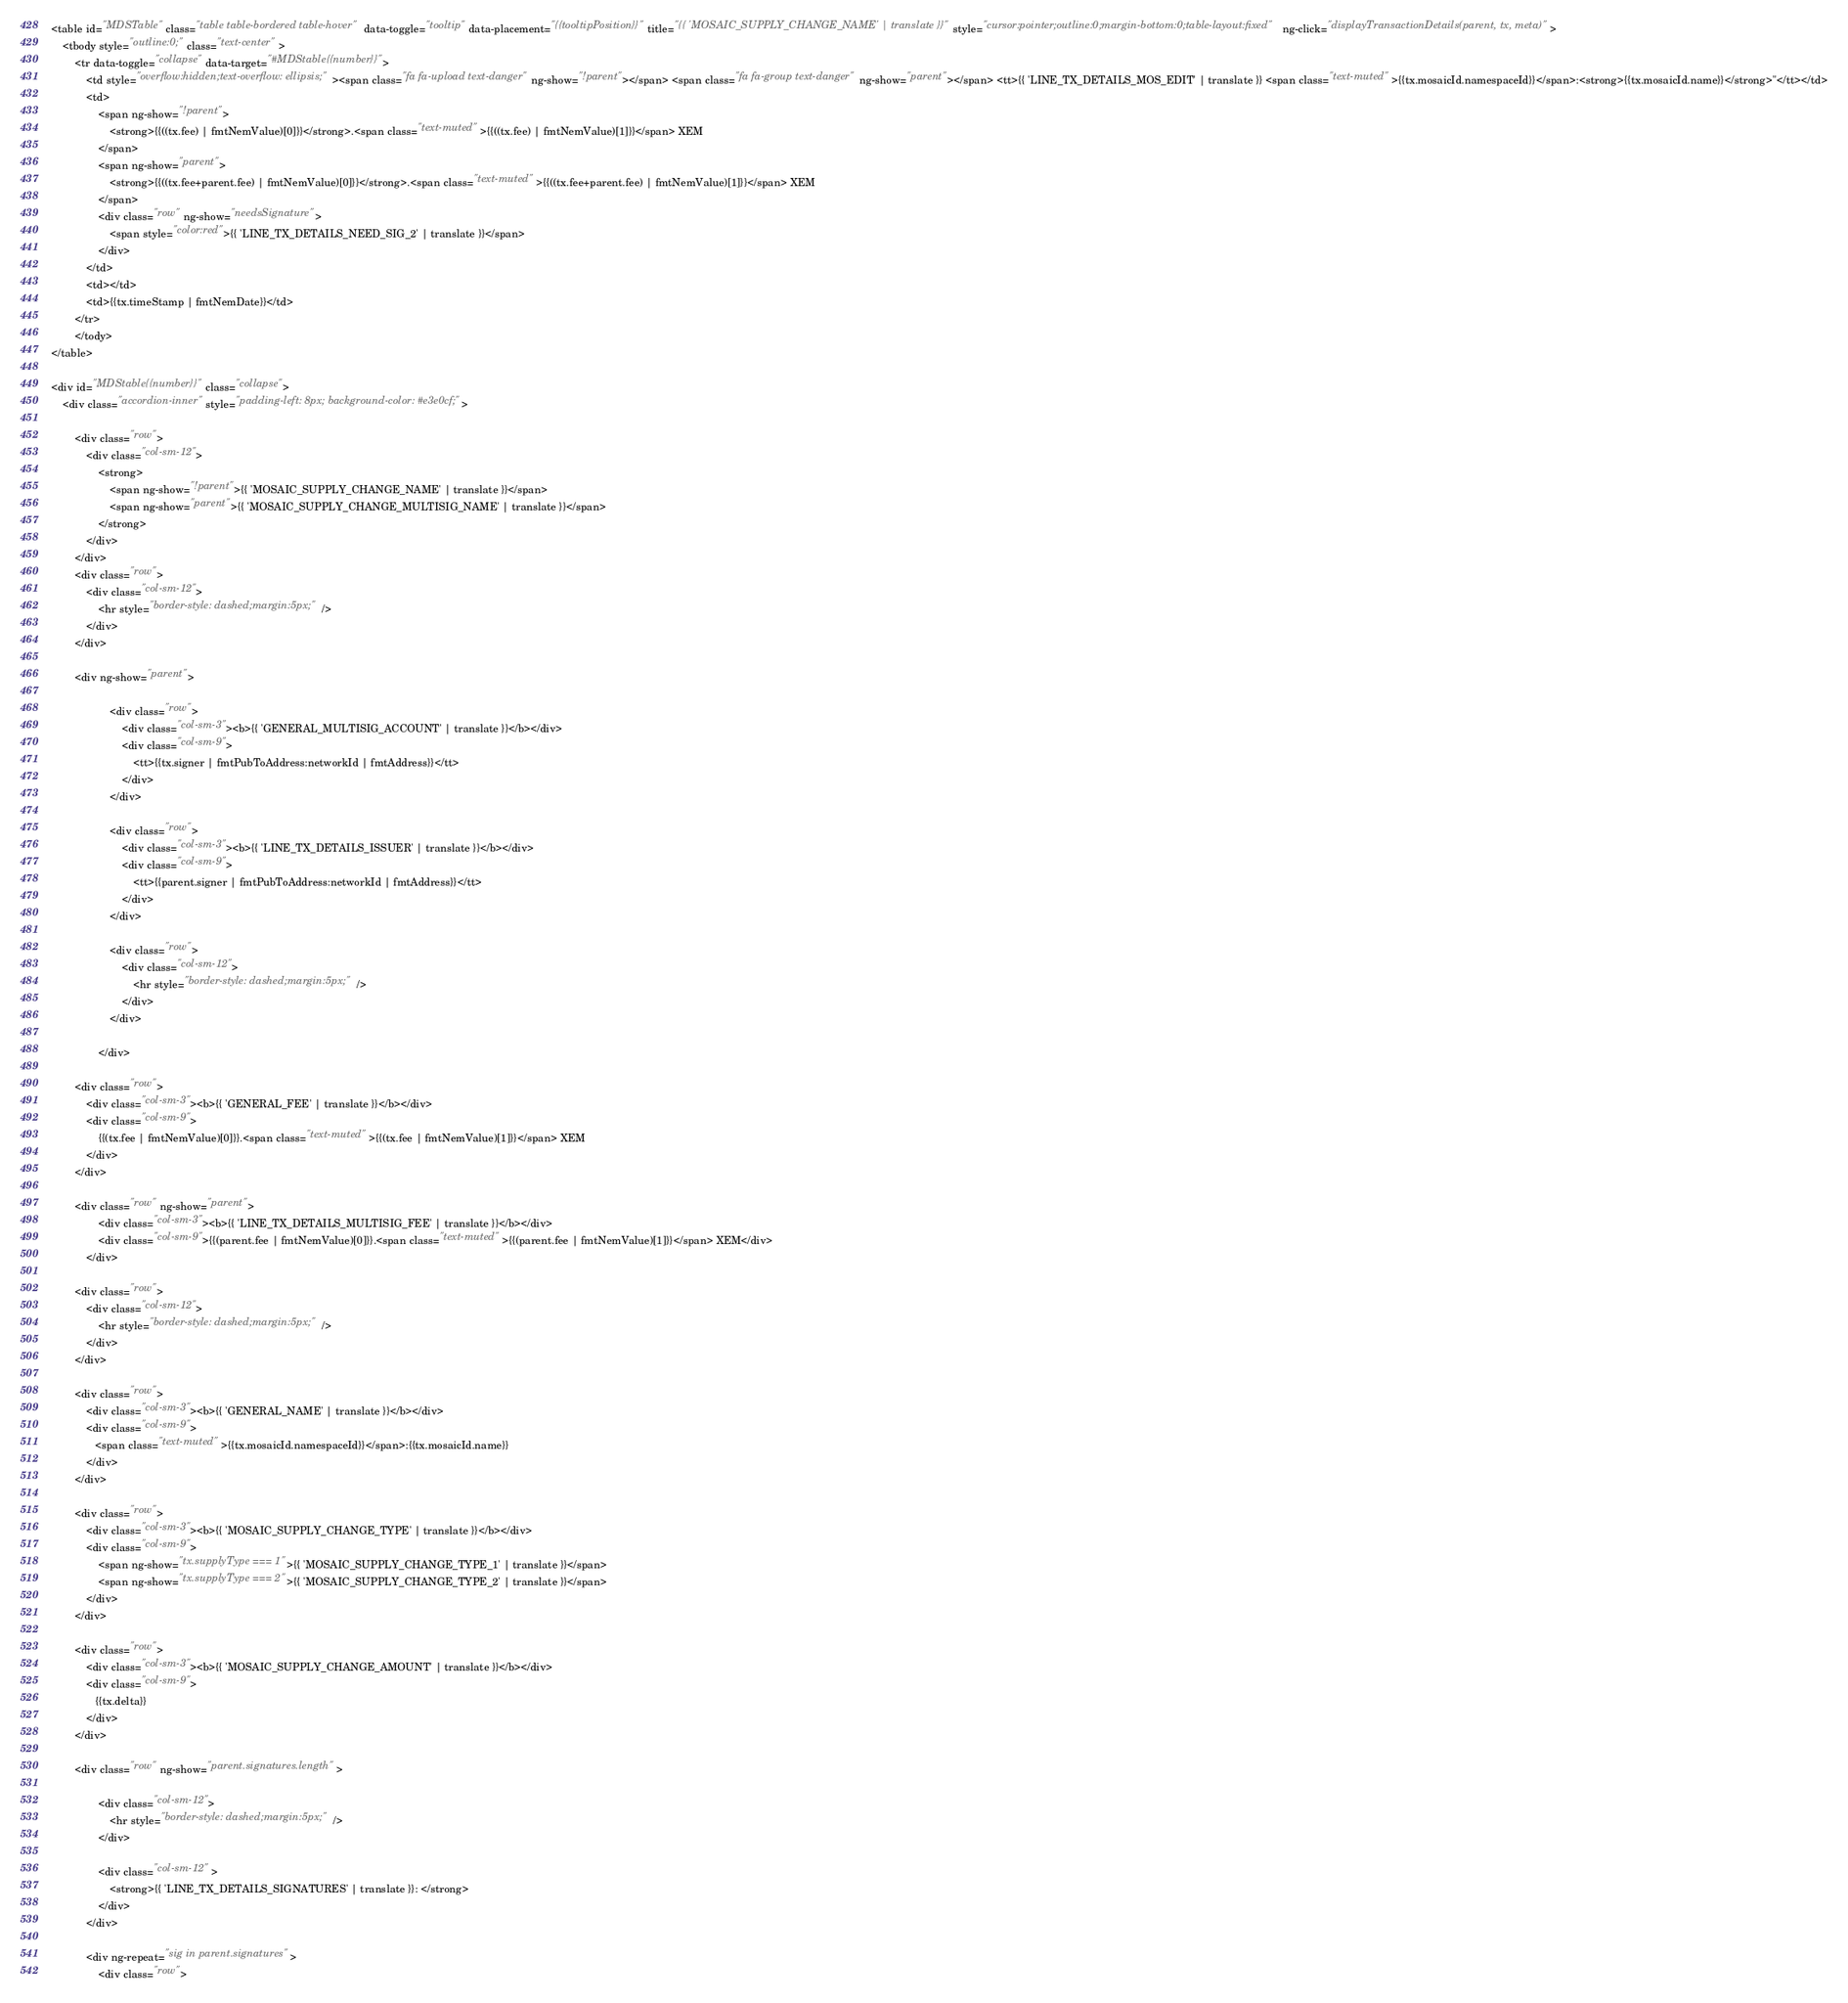Convert code to text. <code><loc_0><loc_0><loc_500><loc_500><_HTML_><table id="MDSTable" class="table table-bordered table-hover" data-toggle="tooltip" data-placement="{{tooltipPosition}}" title="{{ 'MOSAIC_SUPPLY_CHANGE_NAME' | translate }}" style="cursor:pointer;outline:0;margin-bottom:0;table-layout:fixed" ng-click="displayTransactionDetails(parent, tx, meta)">
    <tbody style="outline:0;" class="text-center">
        <tr data-toggle="collapse" data-target="#MDStable{{number}}">
            <td style="overflow:hidden;text-overflow: ellipsis;"><span class="fa fa-upload text-danger" ng-show="!parent"></span> <span class="fa fa-group text-danger" ng-show="parent"></span> <tt>{{ 'LINE_TX_DETAILS_MOS_EDIT' | translate }} <span class="text-muted">{{tx.mosaicId.namespaceId}}</span>:<strong>{{tx.mosaicId.name}}</strong>"</tt></td>
            <td>
                <span ng-show="!parent">
                    <strong>{{((tx.fee) | fmtNemValue)[0]}}</strong>.<span class="text-muted">{{((tx.fee) | fmtNemValue)[1]}}</span> XEM
                </span>
                <span ng-show="parent">
                    <strong>{{((tx.fee+parent.fee) | fmtNemValue)[0]}}</strong>.<span class="text-muted">{{((tx.fee+parent.fee) | fmtNemValue)[1]}}</span> XEM
                </span>
                <div class="row" ng-show="needsSignature">
                    <span style="color:red">{{ 'LINE_TX_DETAILS_NEED_SIG_2' | translate }}</span>
                </div>
            </td>
            <td></td>
            <td>{{tx.timeStamp | fmtNemDate}}</td>
        </tr>
        </tody>
</table>

<div id="MDStable{{number}}" class="collapse">
    <div class="accordion-inner" style="padding-left: 8px; background-color: #e3e0cf;">

        <div class="row">
            <div class="col-sm-12">
                <strong>
                    <span ng-show="!parent">{{ 'MOSAIC_SUPPLY_CHANGE_NAME' | translate }}</span>
                    <span ng-show="parent">{{ 'MOSAIC_SUPPLY_CHANGE_MULTISIG_NAME' | translate }}</span>
                </strong>
            </div>
        </div>
        <div class="row">
            <div class="col-sm-12">
                <hr style="border-style: dashed;margin:5px;" />
            </div>
        </div>

        <div ng-show="parent">

                    <div class="row">
                        <div class="col-sm-3"><b>{{ 'GENERAL_MULTISIG_ACCOUNT' | translate }}</b></div>
                        <div class="col-sm-9">
                            <tt>{{tx.signer | fmtPubToAddress:networkId | fmtAddress}}</tt>
                        </div>
                    </div>

                    <div class="row">
                        <div class="col-sm-3"><b>{{ 'LINE_TX_DETAILS_ISSUER' | translate }}</b></div>
                        <div class="col-sm-9">
                            <tt>{{parent.signer | fmtPubToAddress:networkId | fmtAddress}}</tt>
                        </div>
                    </div>

                    <div class="row">
                        <div class="col-sm-12">
                            <hr style="border-style: dashed;margin:5px;" />
                        </div>
                    </div>

                </div>

        <div class="row">
            <div class="col-sm-3"><b>{{ 'GENERAL_FEE' | translate }}</b></div>
            <div class="col-sm-9">
                {{(tx.fee | fmtNemValue)[0]}}.<span class="text-muted">{{(tx.fee | fmtNemValue)[1]}}</span> XEM
            </div>
        </div>

        <div class="row" ng-show="parent">
                <div class="col-sm-3"><b>{{ 'LINE_TX_DETAILS_MULTISIG_FEE' | translate }}</b></div>
                <div class="col-sm-9">{{(parent.fee | fmtNemValue)[0]}}.<span class="text-muted">{{(parent.fee | fmtNemValue)[1]}}</span> XEM</div>
            </div>

        <div class="row">
            <div class="col-sm-12">
                <hr style="border-style: dashed;margin:5px;" />
            </div>
        </div>
        
        <div class="row">
            <div class="col-sm-3"><b>{{ 'GENERAL_NAME' | translate }}</b></div>
            <div class="col-sm-9">
               <span class="text-muted">{{tx.mosaicId.namespaceId}}</span>:{{tx.mosaicId.name}}
            </div>
        </div>

        <div class="row">
            <div class="col-sm-3"><b>{{ 'MOSAIC_SUPPLY_CHANGE_TYPE' | translate }}</b></div>
            <div class="col-sm-9">
                <span ng-show="tx.supplyType === 1">{{ 'MOSAIC_SUPPLY_CHANGE_TYPE_1' | translate }}</span>
                <span ng-show="tx.supplyType === 2">{{ 'MOSAIC_SUPPLY_CHANGE_TYPE_2' | translate }}</span>
            </div>
        </div>

        <div class="row">
            <div class="col-sm-3"><b>{{ 'MOSAIC_SUPPLY_CHANGE_AMOUNT' | translate }}</b></div>
            <div class="col-sm-9">
               {{tx.delta}}
            </div>
        </div>

        <div class="row" ng-show="parent.signatures.length">

                <div class="col-sm-12">
                    <hr style="border-style: dashed;margin:5px;" />
                </div>

                <div class="col-sm-12" >
                    <strong>{{ 'LINE_TX_DETAILS_SIGNATURES' | translate }}: </strong>
                </div>
            </div>

            <div ng-repeat="sig in parent.signatures">
                <div class="row"></code> 